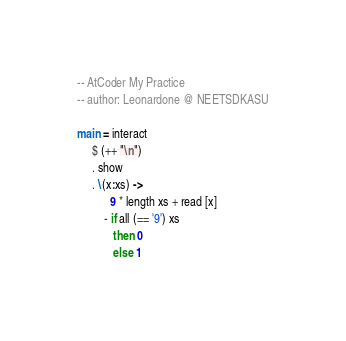Convert code to text. <code><loc_0><loc_0><loc_500><loc_500><_Haskell_>-- AtCoder My Practice
-- author: Leonardone @ NEETSDKASU

main = interact
     $ (++ "\n")
     . show
     . \(x:xs) ->
           9 * length xs + read [x]
         - if all (== '9') xs
            then 0
            else 1
</code> 